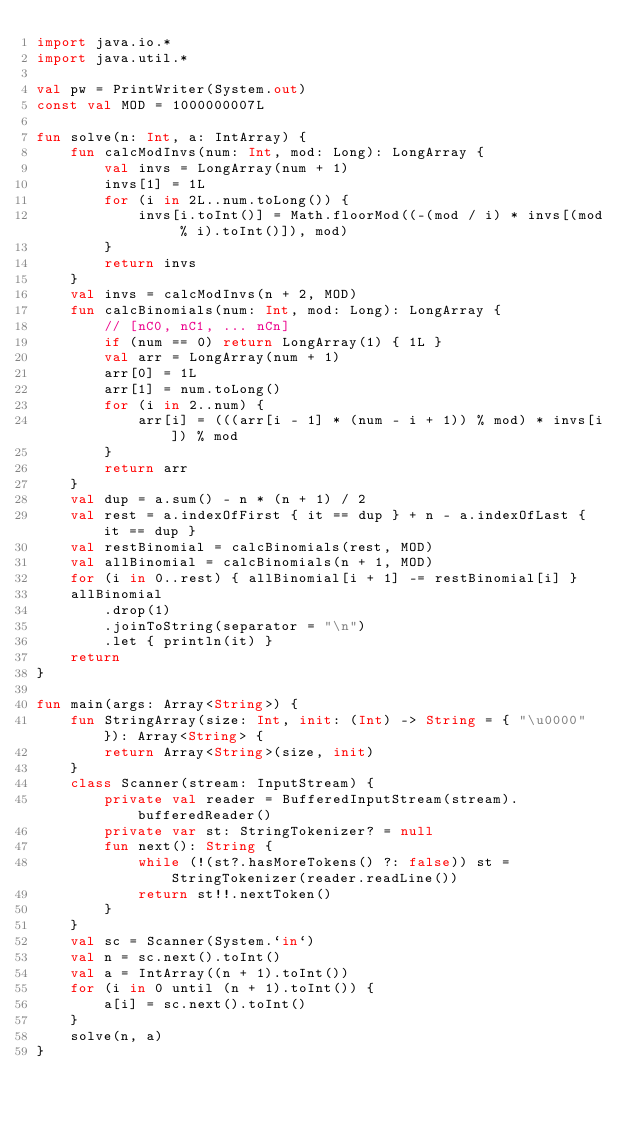Convert code to text. <code><loc_0><loc_0><loc_500><loc_500><_Kotlin_>import java.io.*
import java.util.*

val pw = PrintWriter(System.out)
const val MOD = 1000000007L

fun solve(n: Int, a: IntArray) {
    fun calcModInvs(num: Int, mod: Long): LongArray {
        val invs = LongArray(num + 1)
        invs[1] = 1L
        for (i in 2L..num.toLong()) {
            invs[i.toInt()] = Math.floorMod((-(mod / i) * invs[(mod % i).toInt()]), mod)
        }
        return invs
    }
    val invs = calcModInvs(n + 2, MOD)
    fun calcBinomials(num: Int, mod: Long): LongArray {
        // [nC0, nC1, ... nCn]
        if (num == 0) return LongArray(1) { 1L }
        val arr = LongArray(num + 1)
        arr[0] = 1L
        arr[1] = num.toLong()
        for (i in 2..num) {
            arr[i] = (((arr[i - 1] * (num - i + 1)) % mod) * invs[i]) % mod
        }
        return arr
    }
    val dup = a.sum() - n * (n + 1) / 2
    val rest = a.indexOfFirst { it == dup } + n - a.indexOfLast { it == dup }
    val restBinomial = calcBinomials(rest, MOD)
    val allBinomial = calcBinomials(n + 1, MOD)
    for (i in 0..rest) { allBinomial[i + 1] -= restBinomial[i] }
    allBinomial
        .drop(1)
        .joinToString(separator = "\n")
        .let { println(it) }
    return
}

fun main(args: Array<String>) {
    fun StringArray(size: Int, init: (Int) -> String = { "\u0000" }): Array<String> {
        return Array<String>(size, init)
    }
    class Scanner(stream: InputStream) {
        private val reader = BufferedInputStream(stream).bufferedReader()
        private var st: StringTokenizer? = null
        fun next(): String {
            while (!(st?.hasMoreTokens() ?: false)) st = StringTokenizer(reader.readLine())
            return st!!.nextToken()
        }
    }
    val sc = Scanner(System.`in`)
    val n = sc.next().toInt()
    val a = IntArray((n + 1).toInt())
    for (i in 0 until (n + 1).toInt()) {
        a[i] = sc.next().toInt()
    }
    solve(n, a)
}
</code> 